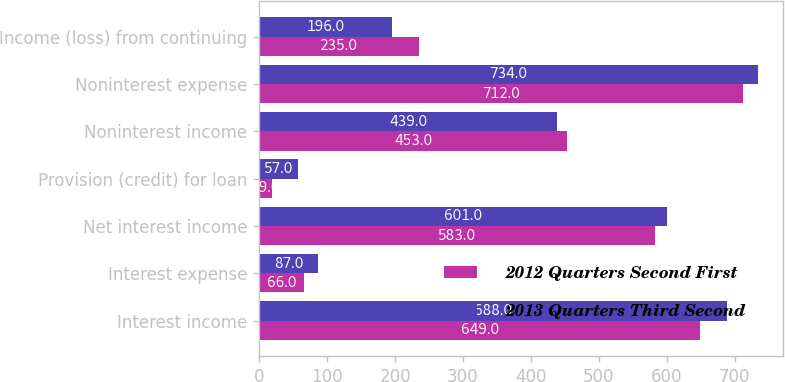<chart> <loc_0><loc_0><loc_500><loc_500><stacked_bar_chart><ecel><fcel>Interest income<fcel>Interest expense<fcel>Net interest income<fcel>Provision (credit) for loan<fcel>Noninterest income<fcel>Noninterest expense<fcel>Income (loss) from continuing<nl><fcel>2012 Quarters Second First<fcel>649<fcel>66<fcel>583<fcel>19<fcel>453<fcel>712<fcel>235<nl><fcel>2013 Quarters Third Second<fcel>688<fcel>87<fcel>601<fcel>57<fcel>439<fcel>734<fcel>196<nl></chart> 